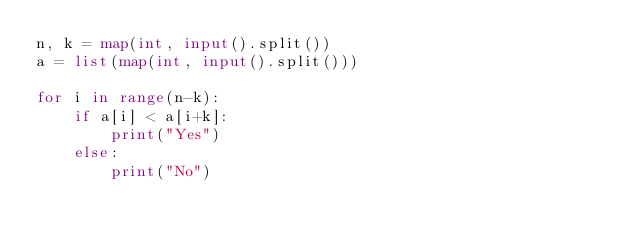Convert code to text. <code><loc_0><loc_0><loc_500><loc_500><_Python_>n, k = map(int, input().split())
a = list(map(int, input().split()))

for i in range(n-k):
    if a[i] < a[i+k]:
        print("Yes")
    else:
        print("No")
</code> 